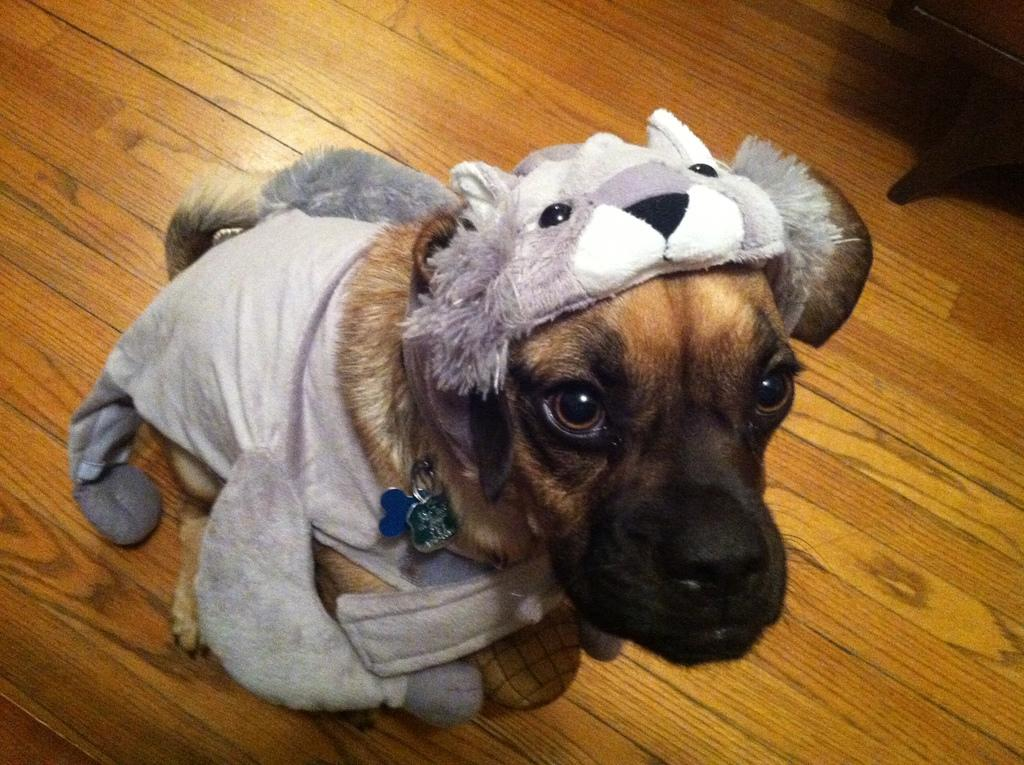What type of animal is in the image? There is a dog in the image. What is unique about the dog's appearance? The dog is wearing different costumes. What type of surface is visible in the image? The wooden surface is present in the image. How many sisters are present in the image? There are no sisters mentioned or depicted in the image. What type of cat can be seen playing with the dog in the image? There is no cat present in the image; it features a dog wearing different costumes. 